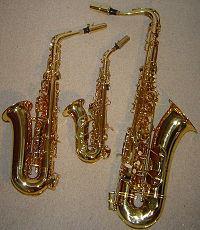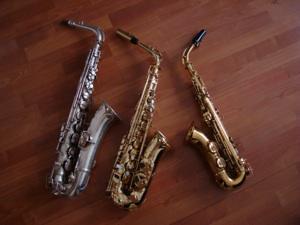The first image is the image on the left, the second image is the image on the right. Analyze the images presented: Is the assertion "At least one image contains exactly three saxophones, and no image shows a saxophone broken down into parts." valid? Answer yes or no. Yes. The first image is the image on the left, the second image is the image on the right. Considering the images on both sides, is "In one image, exactly three saxophones are the same metallic color, but are different sizes and have different types of mouthpieces." valid? Answer yes or no. Yes. 